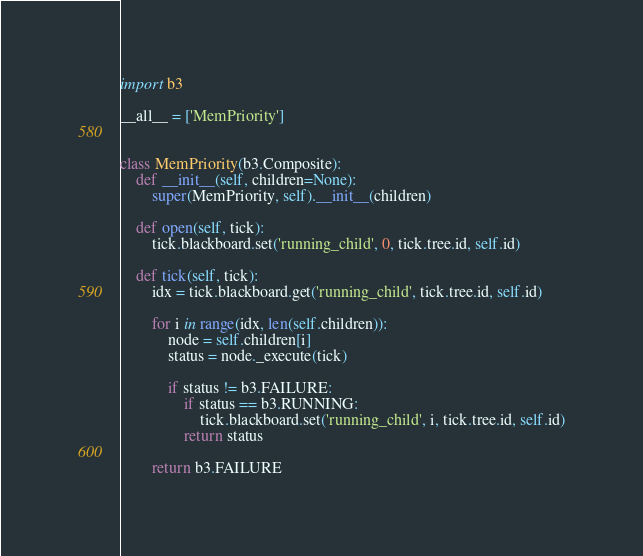Convert code to text. <code><loc_0><loc_0><loc_500><loc_500><_Python_>import b3

__all__ = ['MemPriority']


class MemPriority(b3.Composite):
    def __init__(self, children=None):
        super(MemPriority, self).__init__(children)

    def open(self, tick):
        tick.blackboard.set('running_child', 0, tick.tree.id, self.id)

    def tick(self, tick):
        idx = tick.blackboard.get('running_child', tick.tree.id, self.id)

        for i in range(idx, len(self.children)):
            node = self.children[i]
            status = node._execute(tick)

            if status != b3.FAILURE:
                if status == b3.RUNNING:
                    tick.blackboard.set('running_child', i, tick.tree.id, self.id)
                return status

        return b3.FAILURE
</code> 